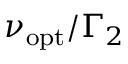<formula> <loc_0><loc_0><loc_500><loc_500>\nu _ { o p t } / \Gamma _ { 2 }</formula> 